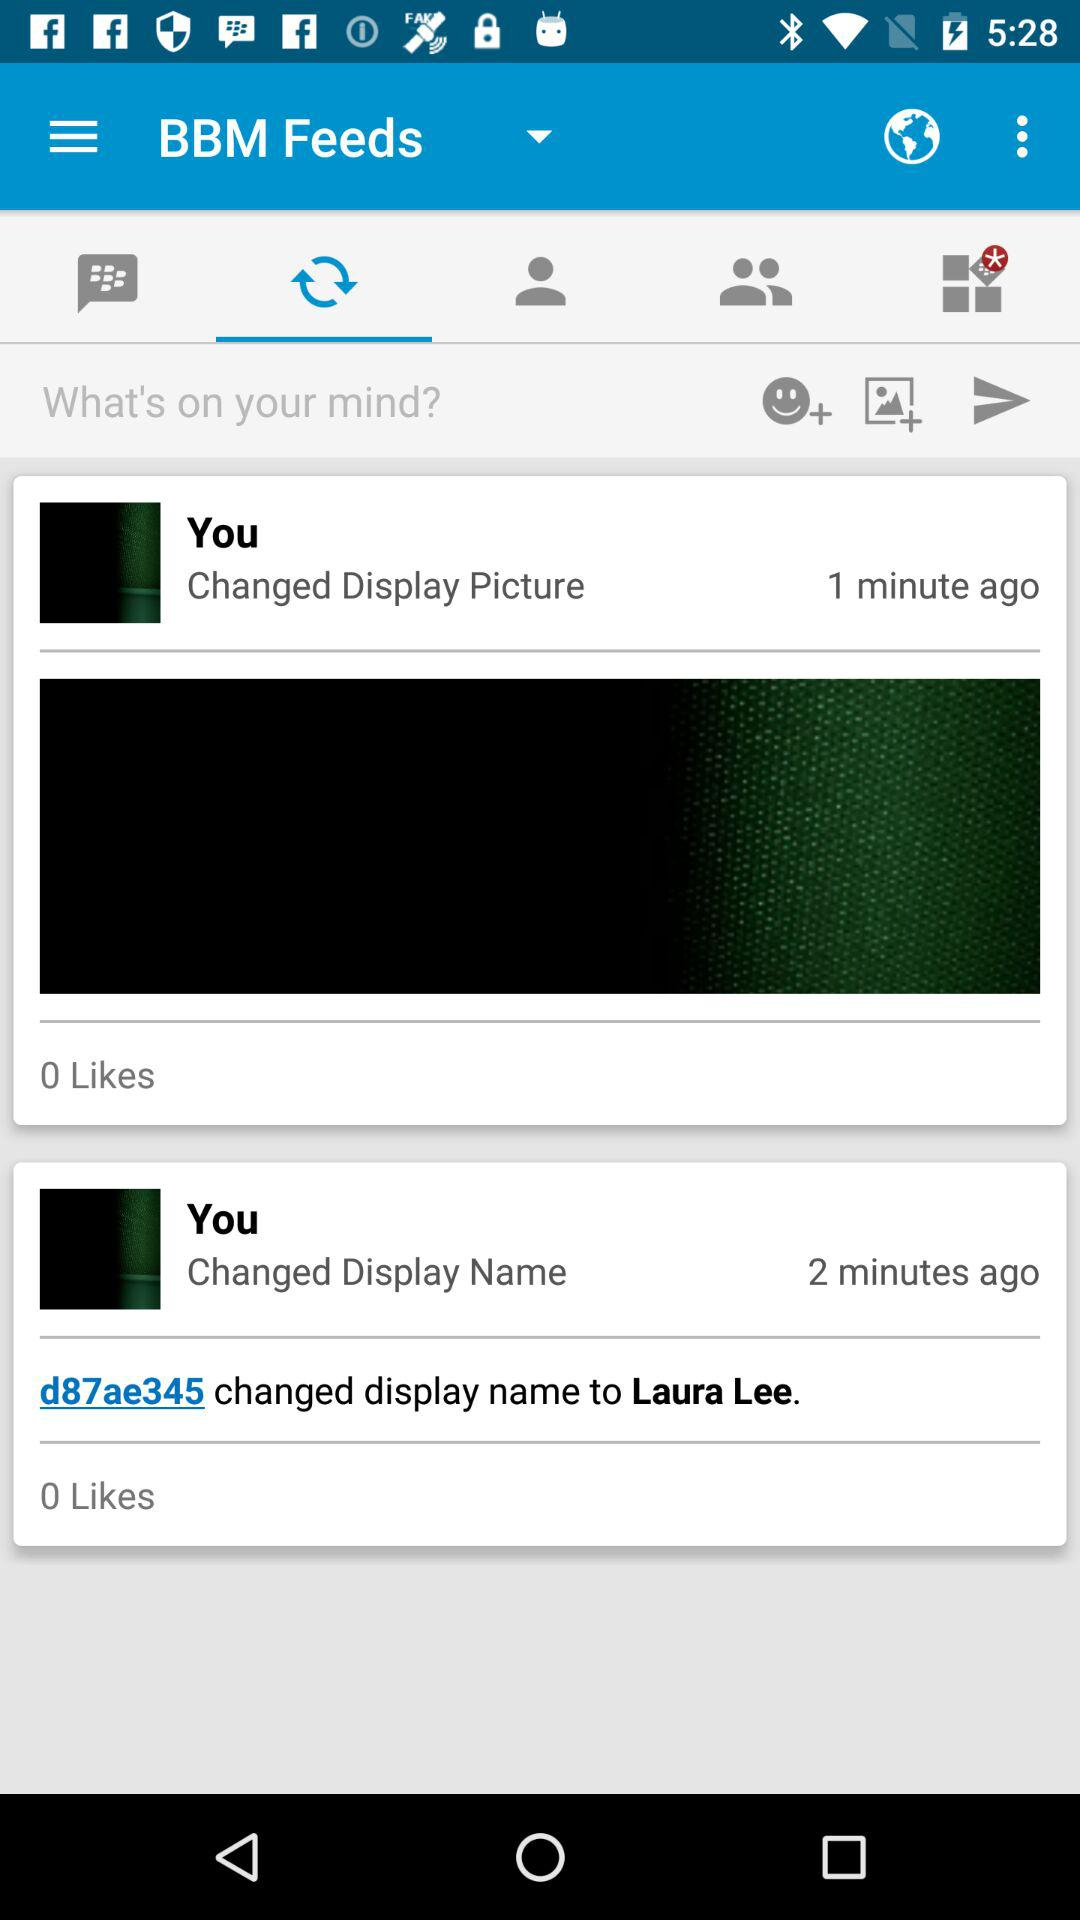How many likes does the first display picture change have?
Answer the question using a single word or phrase. 0 